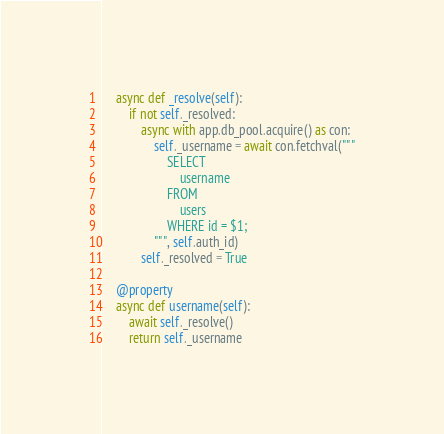Convert code to text. <code><loc_0><loc_0><loc_500><loc_500><_Python_>
    async def _resolve(self):
        if not self._resolved:
            async with app.db_pool.acquire() as con:
                self._username = await con.fetchval("""
                    SELECT
                        username
                    FROM
                        users
                    WHERE id = $1;
                """, self.auth_id)
            self._resolved = True

    @property
    async def username(self):
        await self._resolve()
        return self._username
</code> 